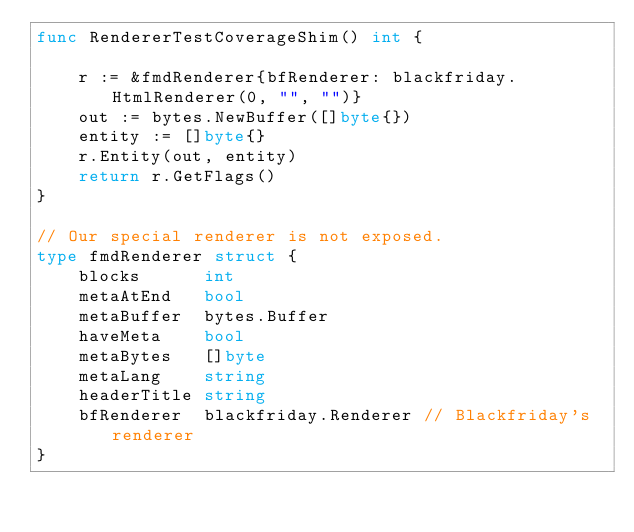Convert code to text. <code><loc_0><loc_0><loc_500><loc_500><_Go_>func RendererTestCoverageShim() int {

	r := &fmdRenderer{bfRenderer: blackfriday.HtmlRenderer(0, "", "")}
	out := bytes.NewBuffer([]byte{})
	entity := []byte{}
	r.Entity(out, entity)
	return r.GetFlags()
}

// Our special renderer is not exposed.
type fmdRenderer struct {
	blocks      int
	metaAtEnd   bool
	metaBuffer  bytes.Buffer
	haveMeta    bool
	metaBytes   []byte
	metaLang    string
	headerTitle string
	bfRenderer  blackfriday.Renderer // Blackfriday's renderer
}
</code> 